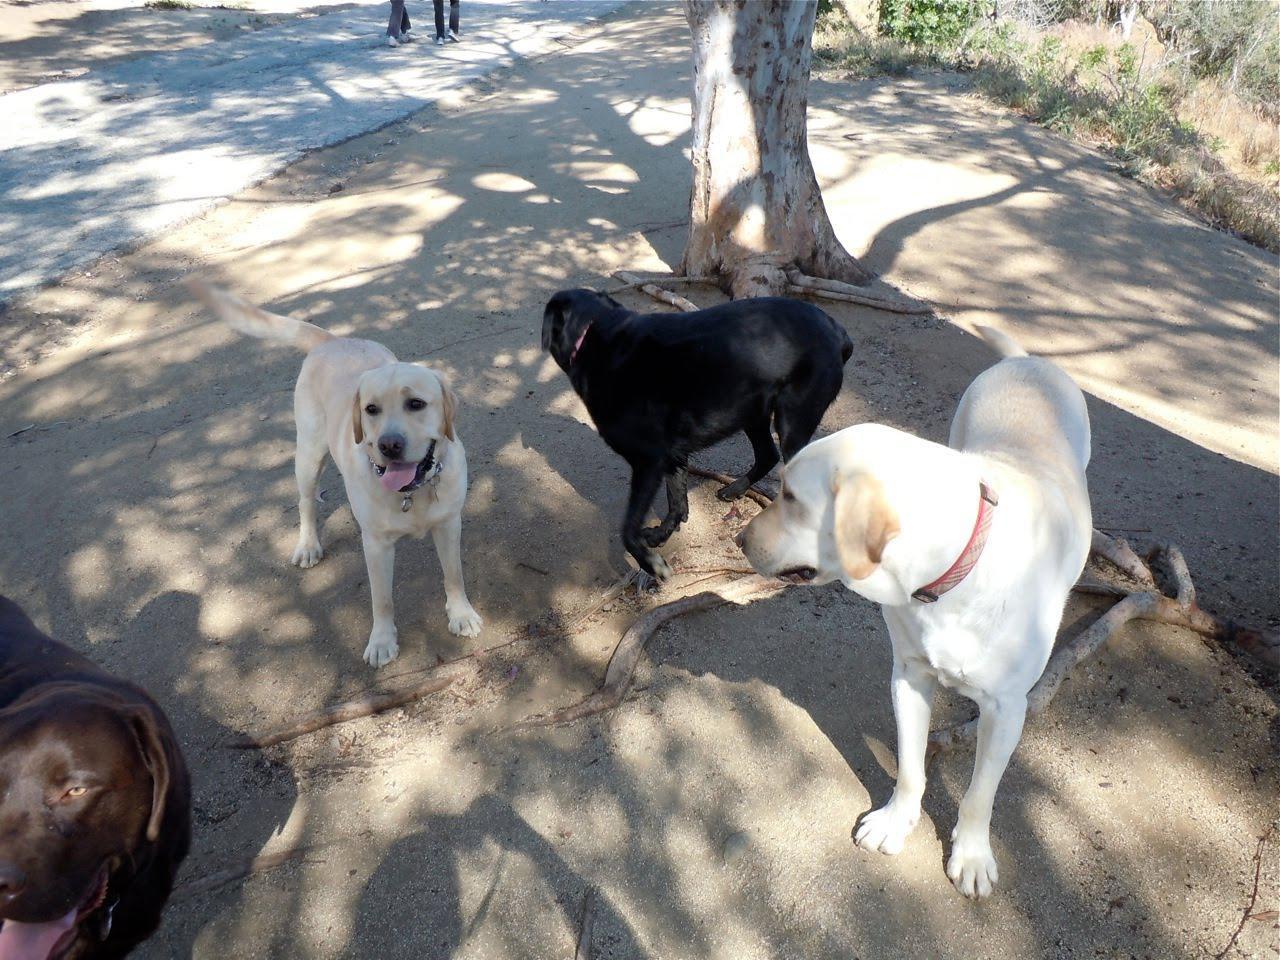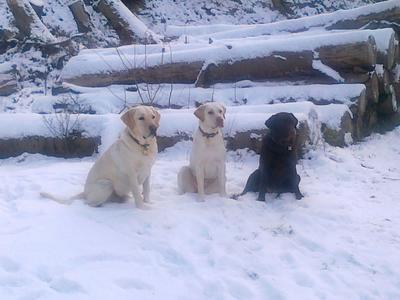The first image is the image on the left, the second image is the image on the right. Evaluate the accuracy of this statement regarding the images: "An image includes eight nearly white dogs of the same breed.". Is it true? Answer yes or no. No. The first image is the image on the left, the second image is the image on the right. Examine the images to the left and right. Is the description "The right image contains exactly three dogs." accurate? Answer yes or no. Yes. 